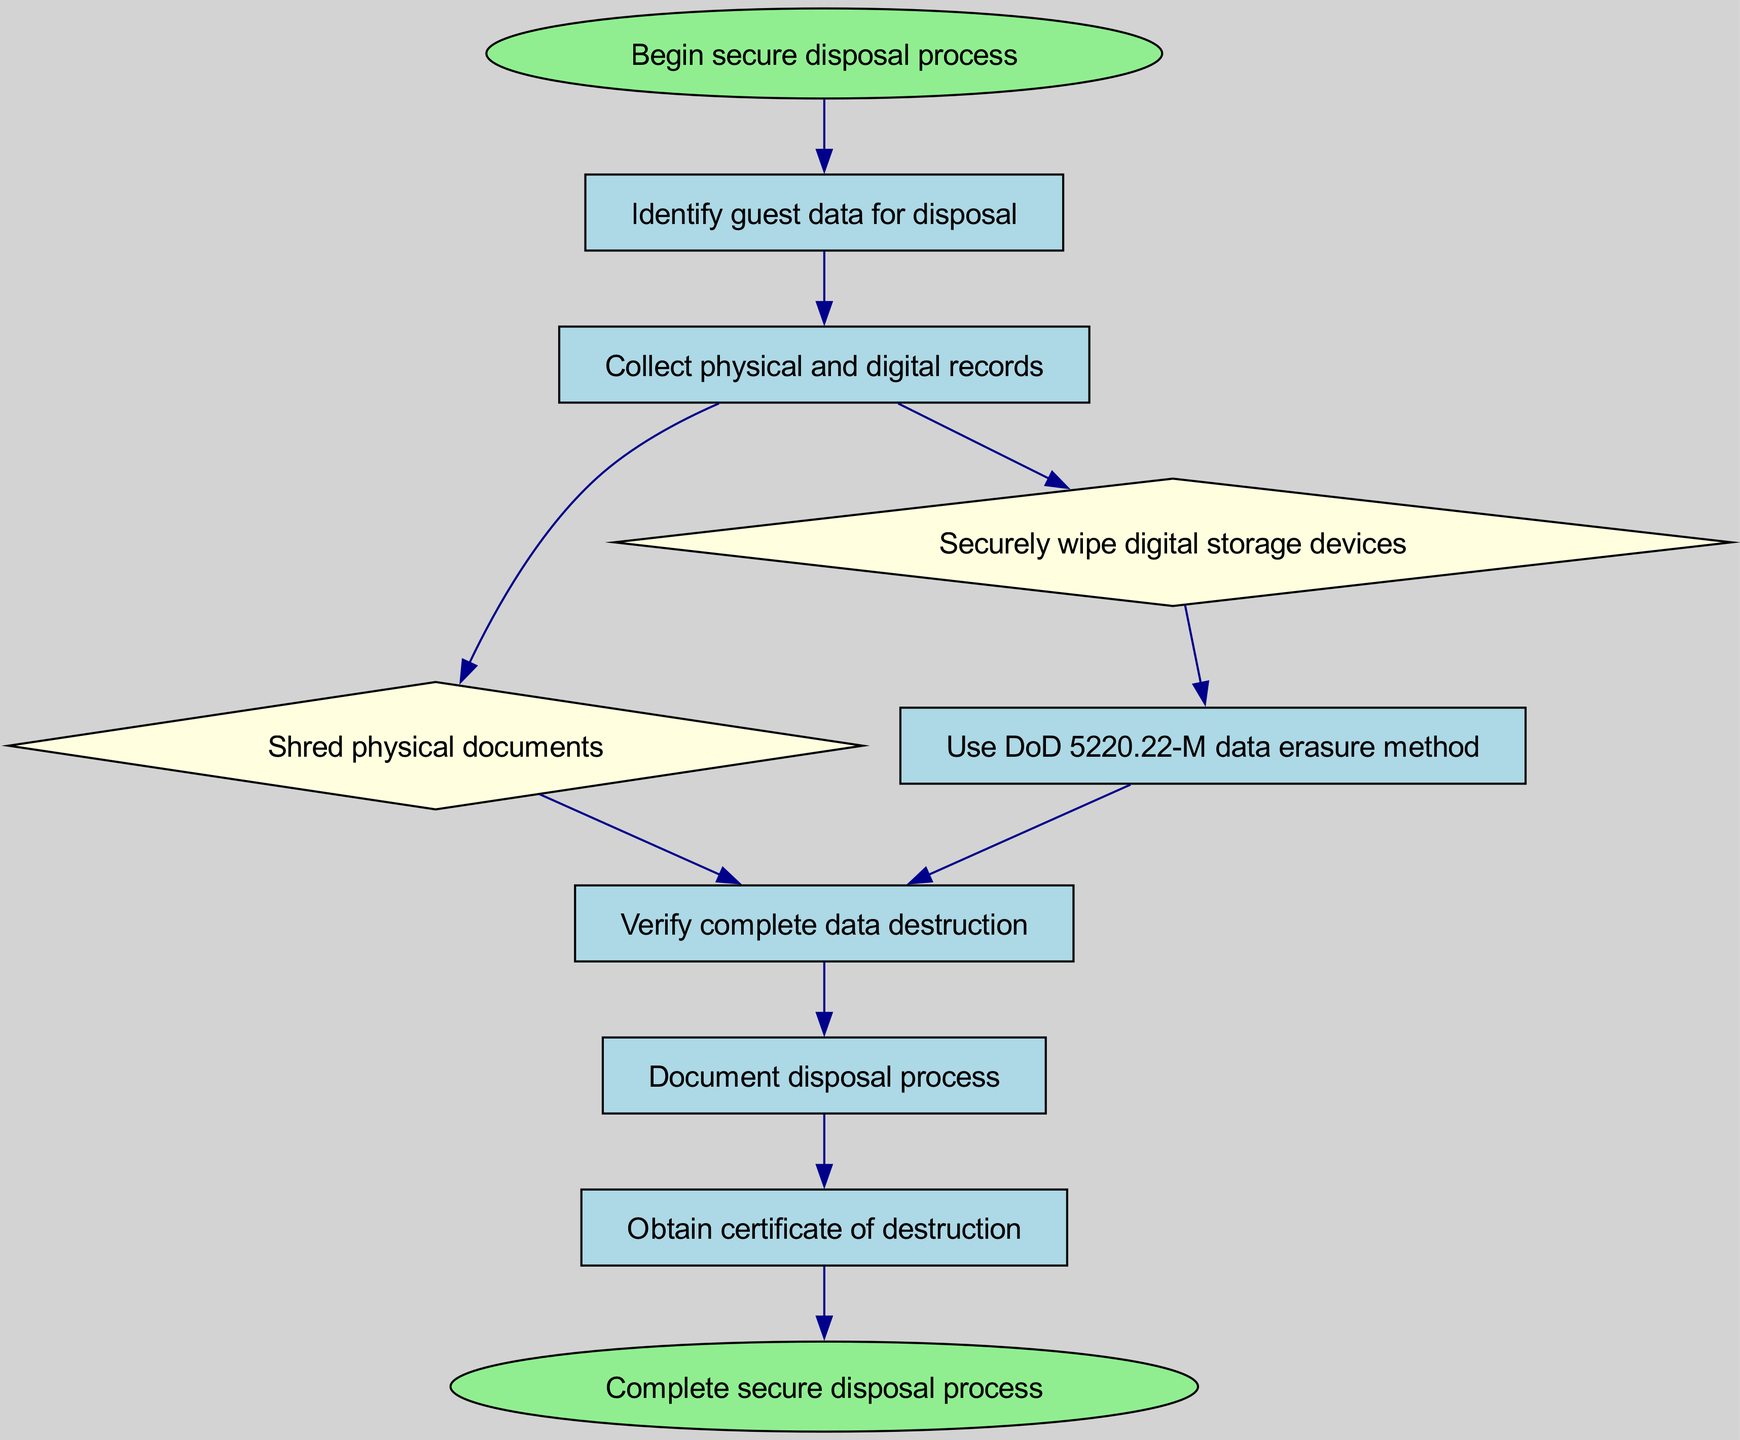What is the first step in the secure disposal process? The first step in the flow chart is labeled "Begin secure disposal process," which indicates that this is where the process starts.
Answer: Begin secure disposal process How many nodes are in the diagram? By counting all the individual labeled steps and the start and end points, there are a total of ten nodes in the diagram.
Answer: Ten What method is used for data erasure in this process? The flow chart specifies the use of "DoD 5220.22-M data erasure method," which is a recognized standard for securely erasing data.
Answer: DoD 5220.22-M data erasure method Which node comes after "Securely wipe digital storage devices"? According to the connections in the flow chart, after "Securely wipe digital storage devices," the next step is "Use DoD 5220.22-M data erasure method."
Answer: Use DoD 5220.22-M data erasure method What two nodes follow the "Collect physical and digital records" node? The "Collect physical and digital records" node leads to two subsequent nodes: "Shred physical documents" and "Securely wipe digital storage devices," indicating two parallel processes.
Answer: Shred physical documents and Securely wipe digital storage devices What is the purpose of the "Document disposal process" step? The "Document disposal process" step is included in the flow chart to emphasize the need for recording the actions taken related to the disposal process for accountability and compliance.
Answer: To document the disposal process How does the diagram indicate verification of data destruction? The diagram indicates verification of data destruction through a node labeled "Verify complete data destruction," which shows that this is a necessary step before proceeding further.
Answer: Verify complete data destruction What occurs immediately before obtaining a certificate of destruction? The flow chart shows that "Document disposal process" occurs immediately before obtaining a "Certificate of destruction," highlighting the need for proper documentation first.
Answer: Document disposal process 